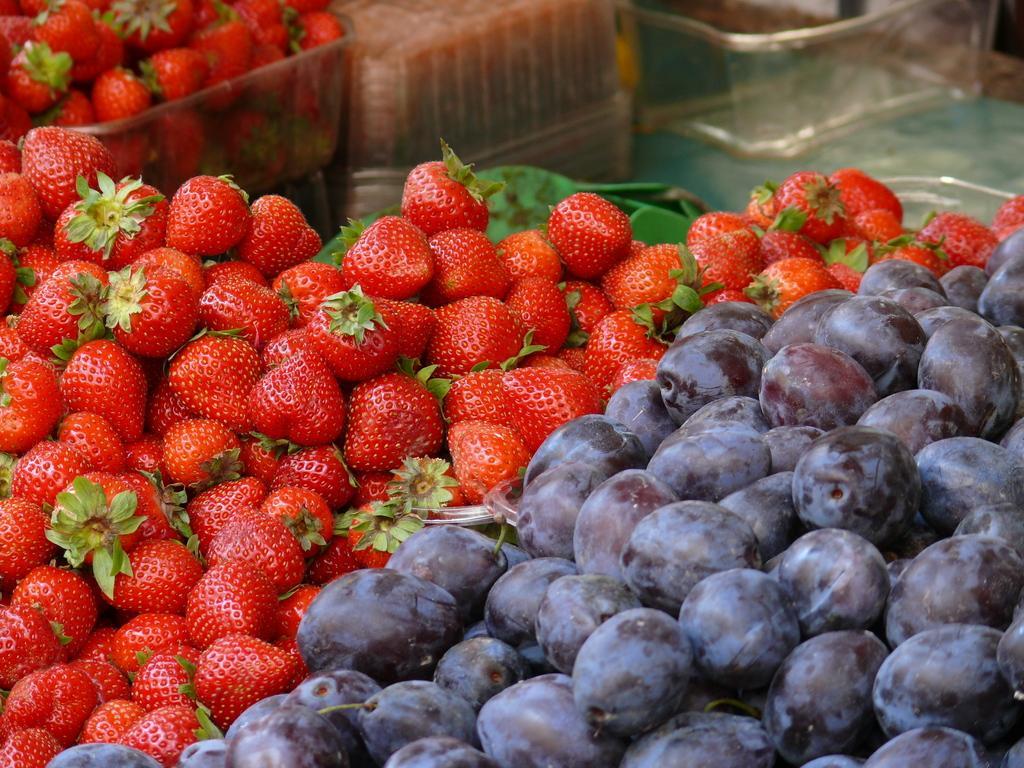Can you describe this image briefly? In this picture I can see strawberries on the left side and black grapes on the right side of the picture and I can see glass trays in the back. 